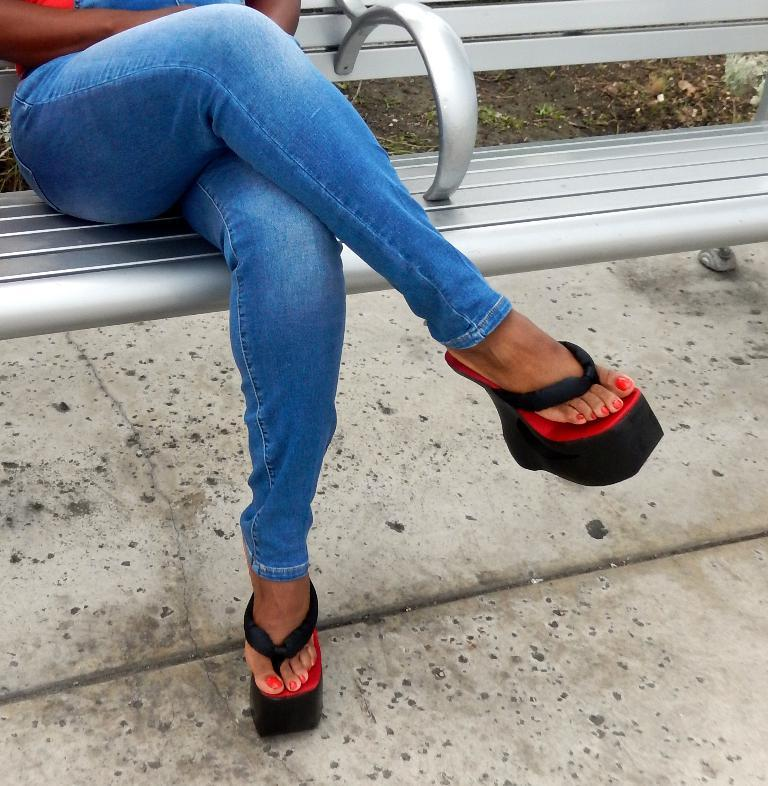What is the person in the image doing? There is a person sitting on a bench in the image. What can be seen beneath the person? The floor is visible in the image. How many bikes are parked next to the person on the bench? There is no information about bikes in the image, so we cannot determine how many bikes are present. 